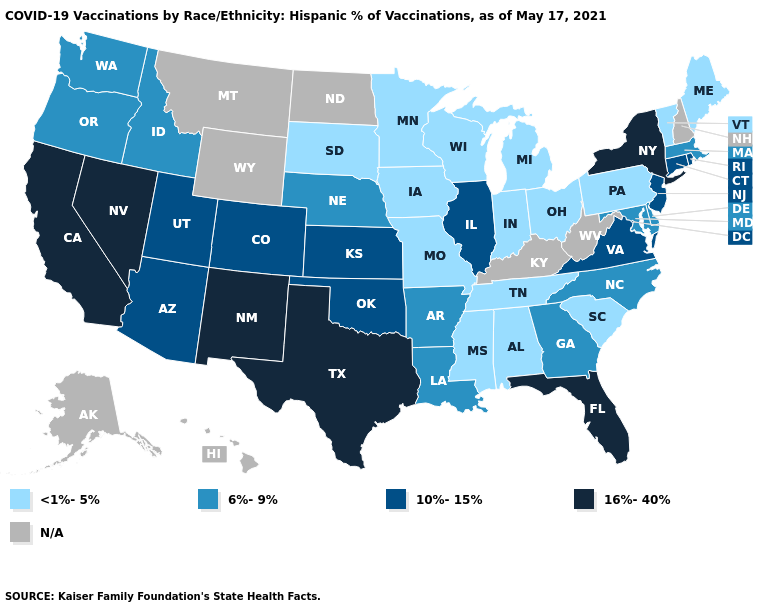Among the states that border Kansas , which have the highest value?
Be succinct. Colorado, Oklahoma. Which states have the lowest value in the Northeast?
Answer briefly. Maine, Pennsylvania, Vermont. Does California have the lowest value in the USA?
Answer briefly. No. Which states have the lowest value in the MidWest?
Write a very short answer. Indiana, Iowa, Michigan, Minnesota, Missouri, Ohio, South Dakota, Wisconsin. Name the states that have a value in the range <1%-5%?
Short answer required. Alabama, Indiana, Iowa, Maine, Michigan, Minnesota, Mississippi, Missouri, Ohio, Pennsylvania, South Carolina, South Dakota, Tennessee, Vermont, Wisconsin. Does the first symbol in the legend represent the smallest category?
Concise answer only. Yes. Is the legend a continuous bar?
Give a very brief answer. No. Does Florida have the highest value in the USA?
Keep it brief. Yes. What is the highest value in the South ?
Write a very short answer. 16%-40%. Which states hav the highest value in the Northeast?
Write a very short answer. New York. What is the highest value in the MidWest ?
Write a very short answer. 10%-15%. Among the states that border Utah , which have the highest value?
Write a very short answer. Nevada, New Mexico. 